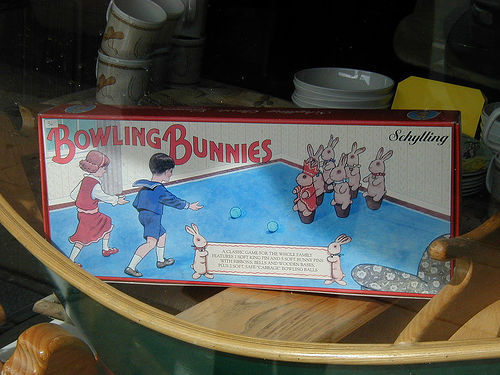<image>
Can you confirm if the box is on the wood boat? Yes. Looking at the image, I can see the box is positioned on top of the wood boat, with the wood boat providing support. 